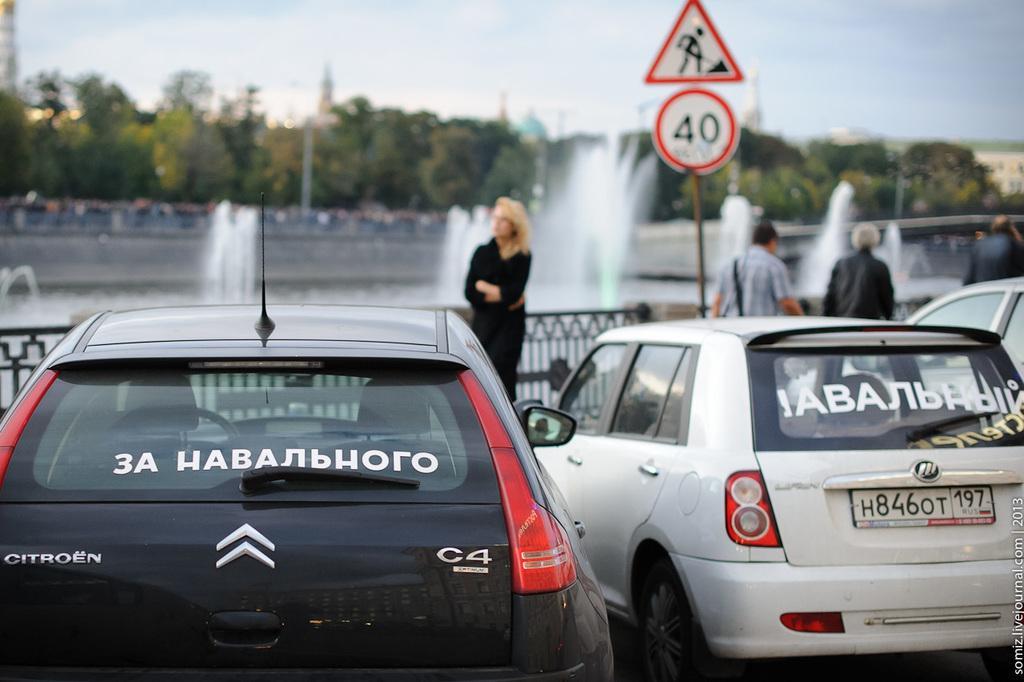Can you describe this image briefly? In this image I can see few vehicles, fencing, fountains, poles, signboards, few people and trees. The sky is in blue and white color. 